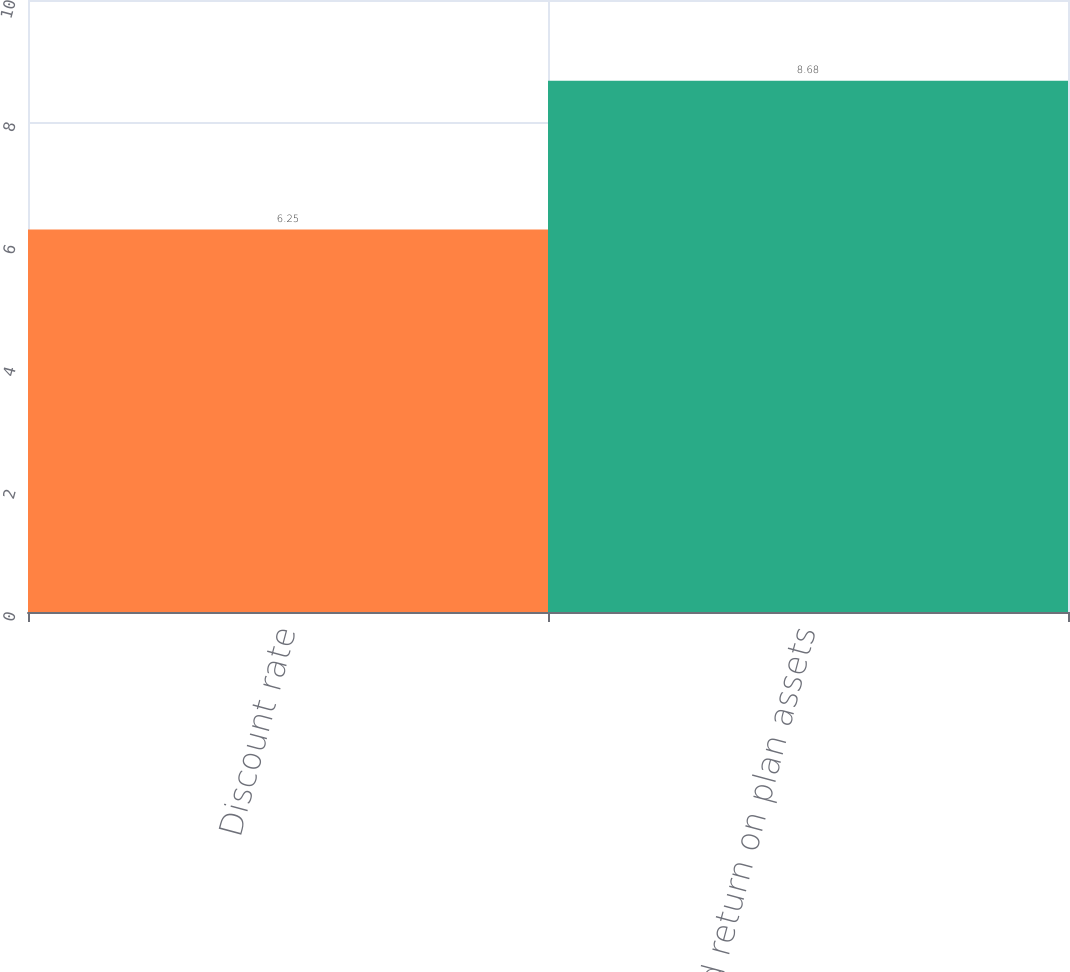Convert chart. <chart><loc_0><loc_0><loc_500><loc_500><bar_chart><fcel>Discount rate<fcel>Expected return on plan assets<nl><fcel>6.25<fcel>8.68<nl></chart> 